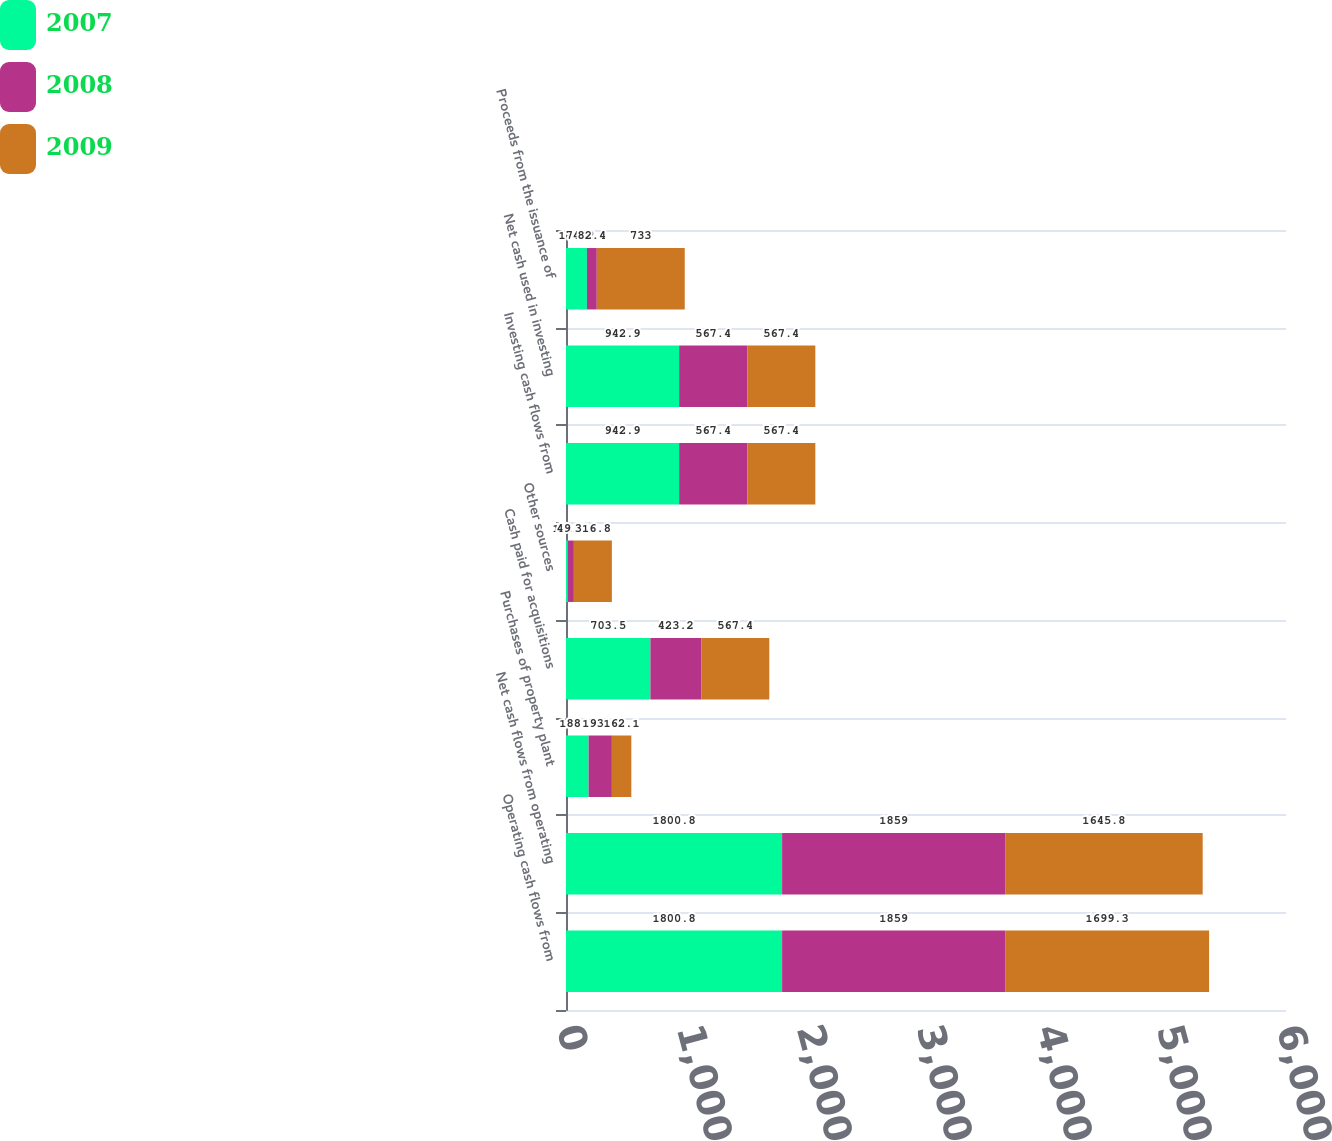<chart> <loc_0><loc_0><loc_500><loc_500><stacked_bar_chart><ecel><fcel>Operating cash flows from<fcel>Net cash flows from operating<fcel>Purchases of property plant<fcel>Cash paid for acquisitions<fcel>Other sources<fcel>Investing cash flows from<fcel>Net cash used in investing<fcel>Proceeds from the issuance of<nl><fcel>2007<fcel>1800.8<fcel>1800.8<fcel>188.5<fcel>703.5<fcel>15.9<fcel>942.9<fcel>942.9<fcel>174.2<nl><fcel>2008<fcel>1859<fcel>1859<fcel>193.8<fcel>423.2<fcel>49.6<fcel>567.4<fcel>567.4<fcel>82.4<nl><fcel>2009<fcel>1699.3<fcel>1645.8<fcel>162.1<fcel>567.4<fcel>316.8<fcel>567.4<fcel>567.4<fcel>733<nl></chart> 